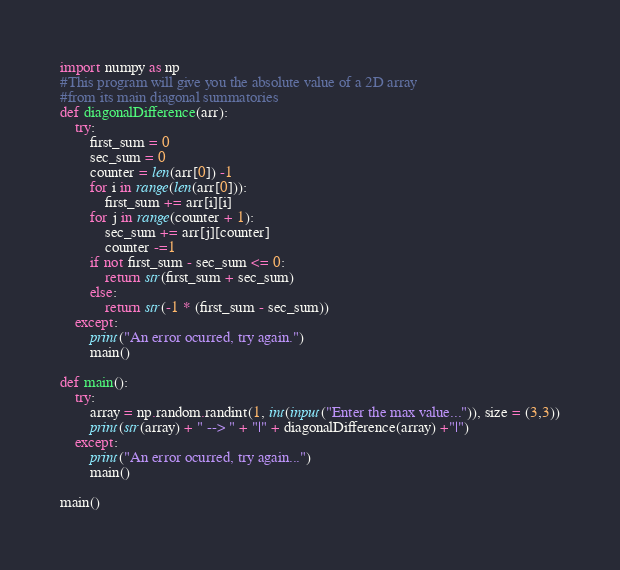Convert code to text. <code><loc_0><loc_0><loc_500><loc_500><_Python_>import numpy as np
#This program will give you the absolute value of a 2D array
#from its main diagonal summatories
def diagonalDifference(arr):
    try:
        first_sum = 0
        sec_sum = 0
        counter = len(arr[0]) -1
        for i in range(len(arr[0])):
            first_sum += arr[i][i]
        for j in range(counter + 1):
            sec_sum += arr[j][counter]
            counter -=1
        if not first_sum - sec_sum <= 0:
            return str(first_sum + sec_sum)
        else:
            return str(-1 * (first_sum - sec_sum))
    except:
        print("An error ocurred, try again.")
        main()

def main():
    try:
        array = np.random.randint(1, int(input("Enter the max value...")), size = (3,3))
        print(str(array) + " --> " + "|" + diagonalDifference(array) +"|")
    except:
        print("An error ocurred, try again...")
        main()

main()</code> 